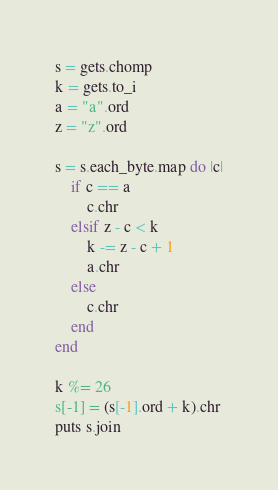Convert code to text. <code><loc_0><loc_0><loc_500><loc_500><_Ruby_>s = gets.chomp
k = gets.to_i
a = "a".ord
z = "z".ord

s = s.each_byte.map do |c|
    if c == a
        c.chr
    elsif z - c < k
        k -= z - c + 1
        a.chr
    else
        c.chr
    end
end

k %= 26
s[-1] = (s[-1].ord + k).chr
puts s.join</code> 